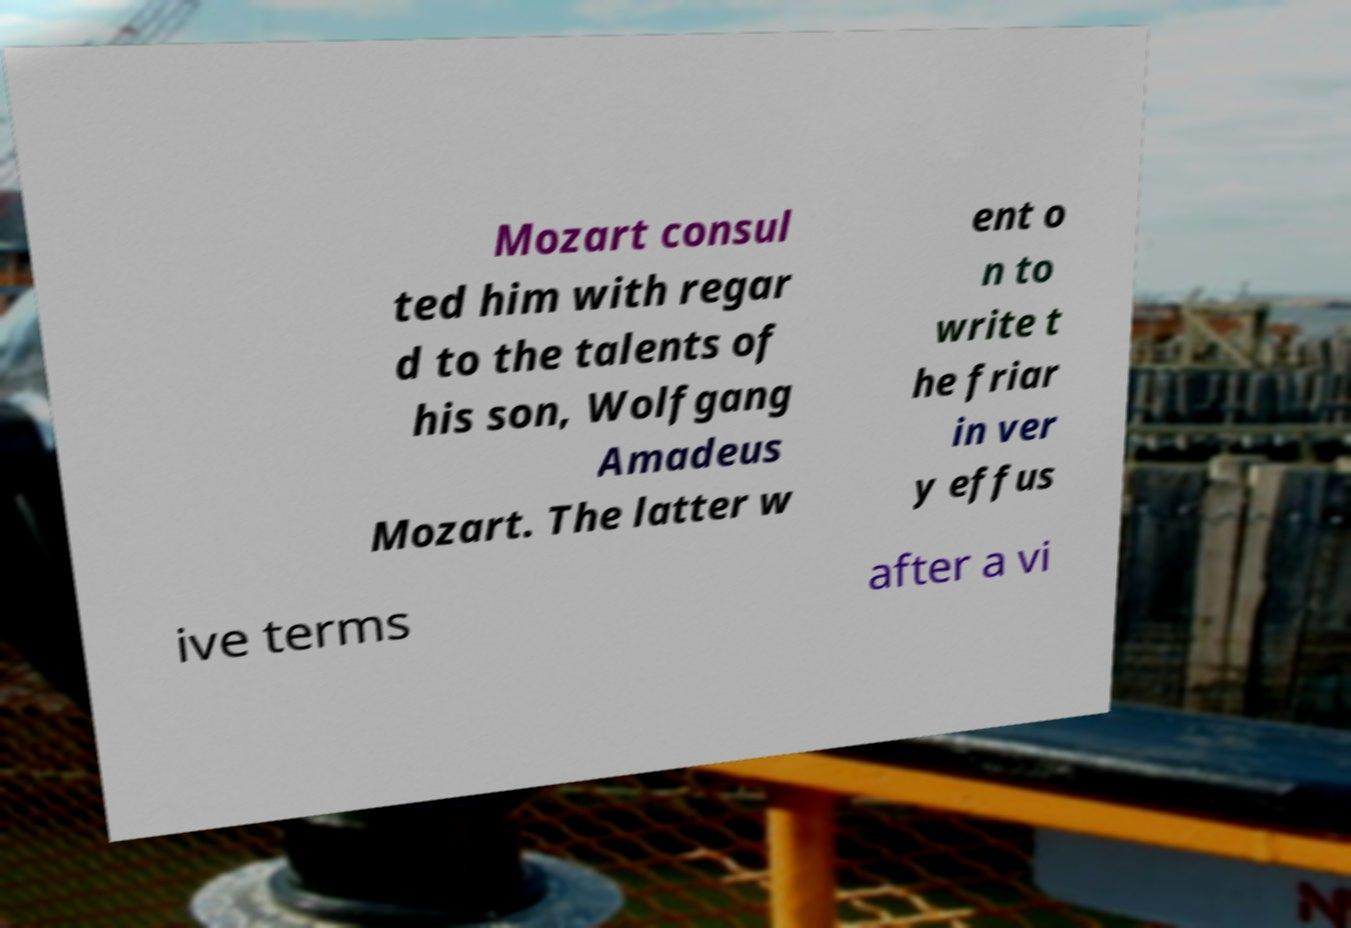Could you assist in decoding the text presented in this image and type it out clearly? Mozart consul ted him with regar d to the talents of his son, Wolfgang Amadeus Mozart. The latter w ent o n to write t he friar in ver y effus ive terms after a vi 